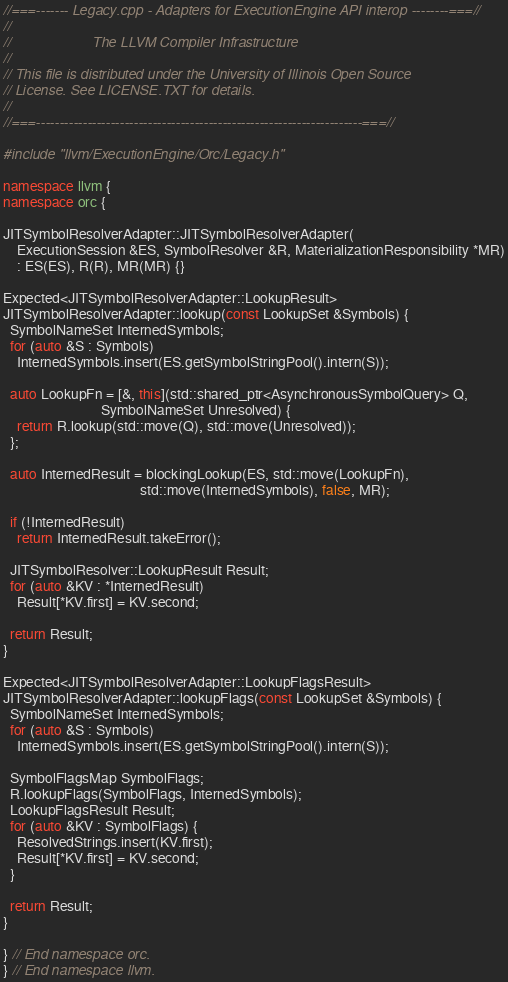<code> <loc_0><loc_0><loc_500><loc_500><_C++_>//===------- Legacy.cpp - Adapters for ExecutionEngine API interop --------===//
//
//                     The LLVM Compiler Infrastructure
//
// This file is distributed under the University of Illinois Open Source
// License. See LICENSE.TXT for details.
//
//===----------------------------------------------------------------------===//

#include "llvm/ExecutionEngine/Orc/Legacy.h"

namespace llvm {
namespace orc {

JITSymbolResolverAdapter::JITSymbolResolverAdapter(
    ExecutionSession &ES, SymbolResolver &R, MaterializationResponsibility *MR)
    : ES(ES), R(R), MR(MR) {}

Expected<JITSymbolResolverAdapter::LookupResult>
JITSymbolResolverAdapter::lookup(const LookupSet &Symbols) {
  SymbolNameSet InternedSymbols;
  for (auto &S : Symbols)
    InternedSymbols.insert(ES.getSymbolStringPool().intern(S));

  auto LookupFn = [&, this](std::shared_ptr<AsynchronousSymbolQuery> Q,
                            SymbolNameSet Unresolved) {
    return R.lookup(std::move(Q), std::move(Unresolved));
  };

  auto InternedResult = blockingLookup(ES, std::move(LookupFn),
                                       std::move(InternedSymbols), false, MR);

  if (!InternedResult)
    return InternedResult.takeError();

  JITSymbolResolver::LookupResult Result;
  for (auto &KV : *InternedResult)
    Result[*KV.first] = KV.second;

  return Result;
}

Expected<JITSymbolResolverAdapter::LookupFlagsResult>
JITSymbolResolverAdapter::lookupFlags(const LookupSet &Symbols) {
  SymbolNameSet InternedSymbols;
  for (auto &S : Symbols)
    InternedSymbols.insert(ES.getSymbolStringPool().intern(S));

  SymbolFlagsMap SymbolFlags;
  R.lookupFlags(SymbolFlags, InternedSymbols);
  LookupFlagsResult Result;
  for (auto &KV : SymbolFlags) {
    ResolvedStrings.insert(KV.first);
    Result[*KV.first] = KV.second;
  }

  return Result;
}

} // End namespace orc.
} // End namespace llvm.
</code> 